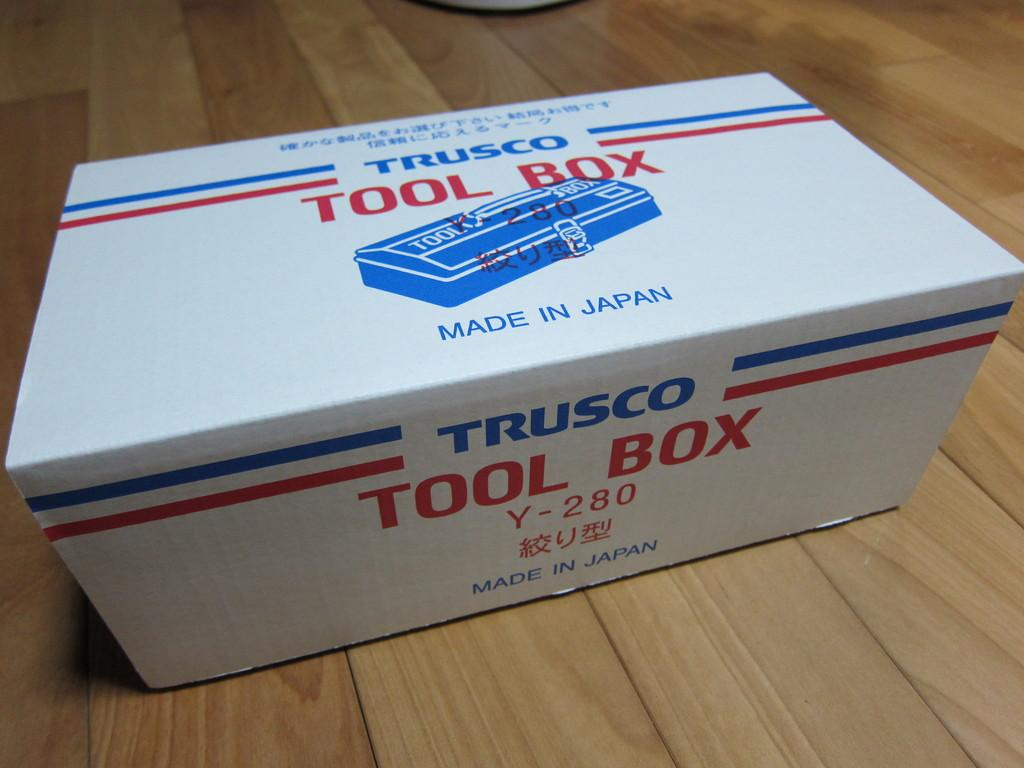<image>
Summarize the visual content of the image. A box made in Japan by Trusco with a Tool Box inside. 